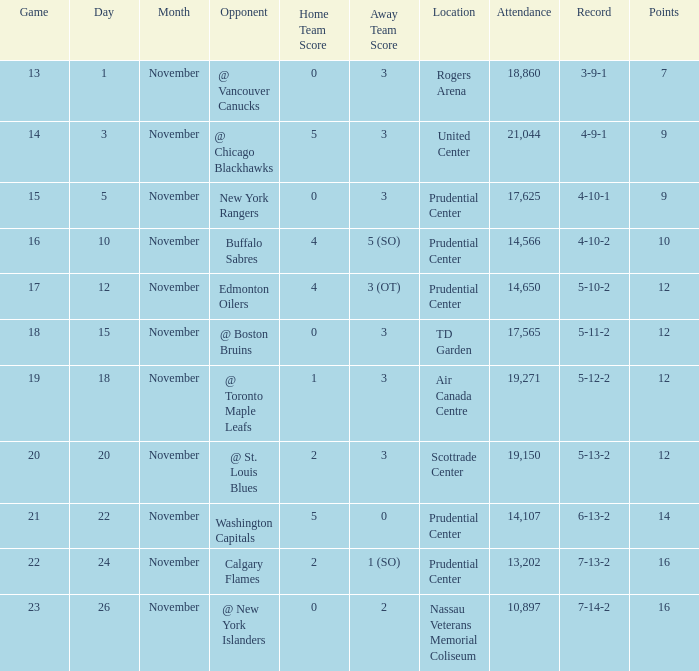Who was the opponent where the game is 14? @ Chicago Blackhawks. 